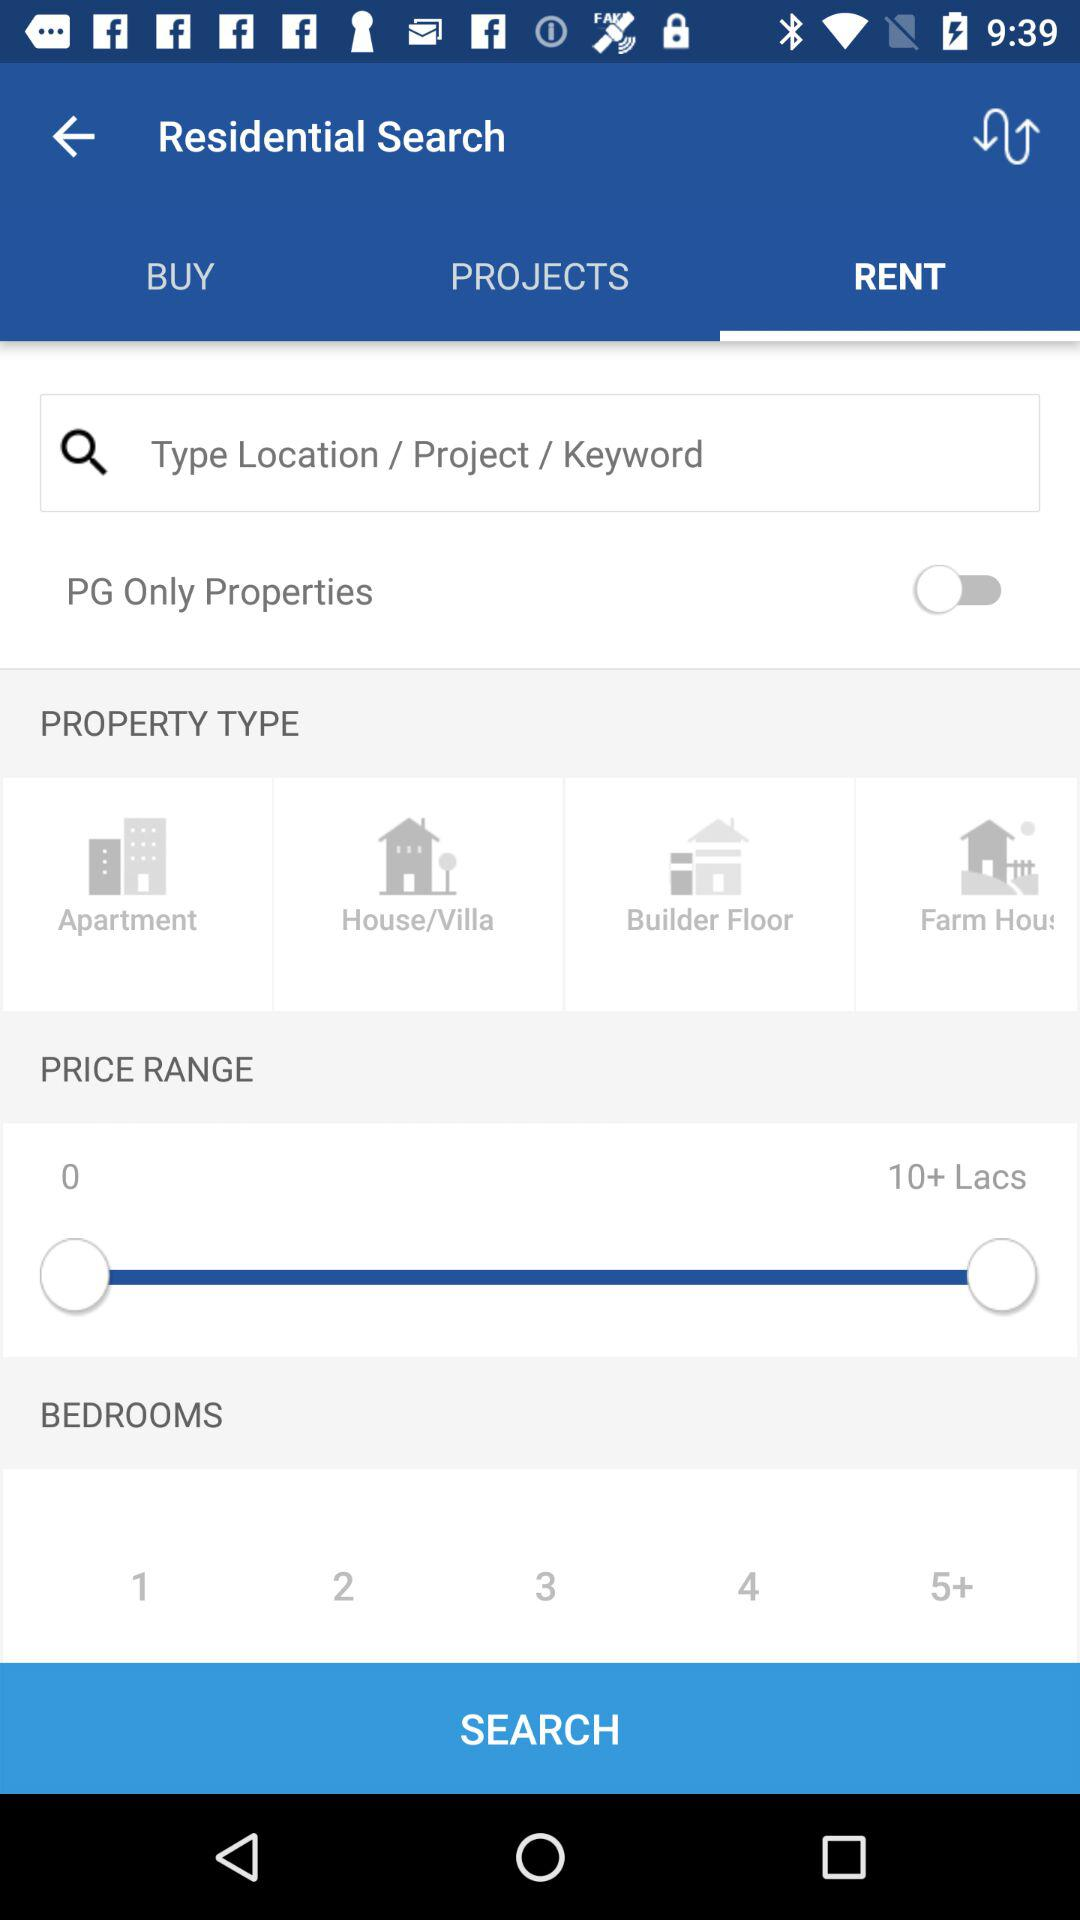Which is the selected tab? The selected tab is "RENT". 